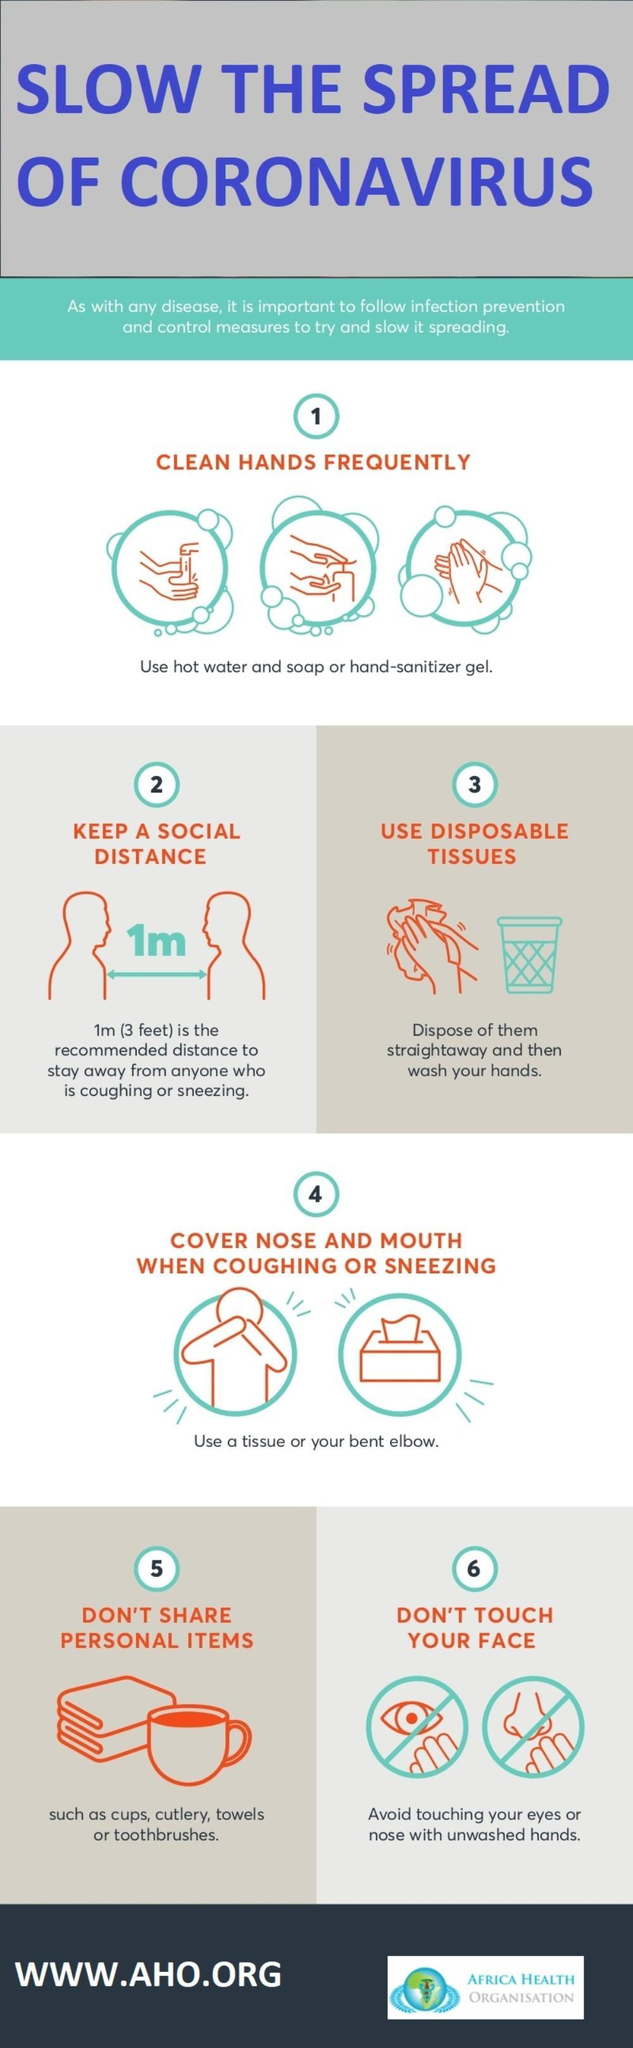Which parts of the face are in this infographic?
Answer the question with a short phrase. eyes, nose How many personal items are in this infographic? 4 